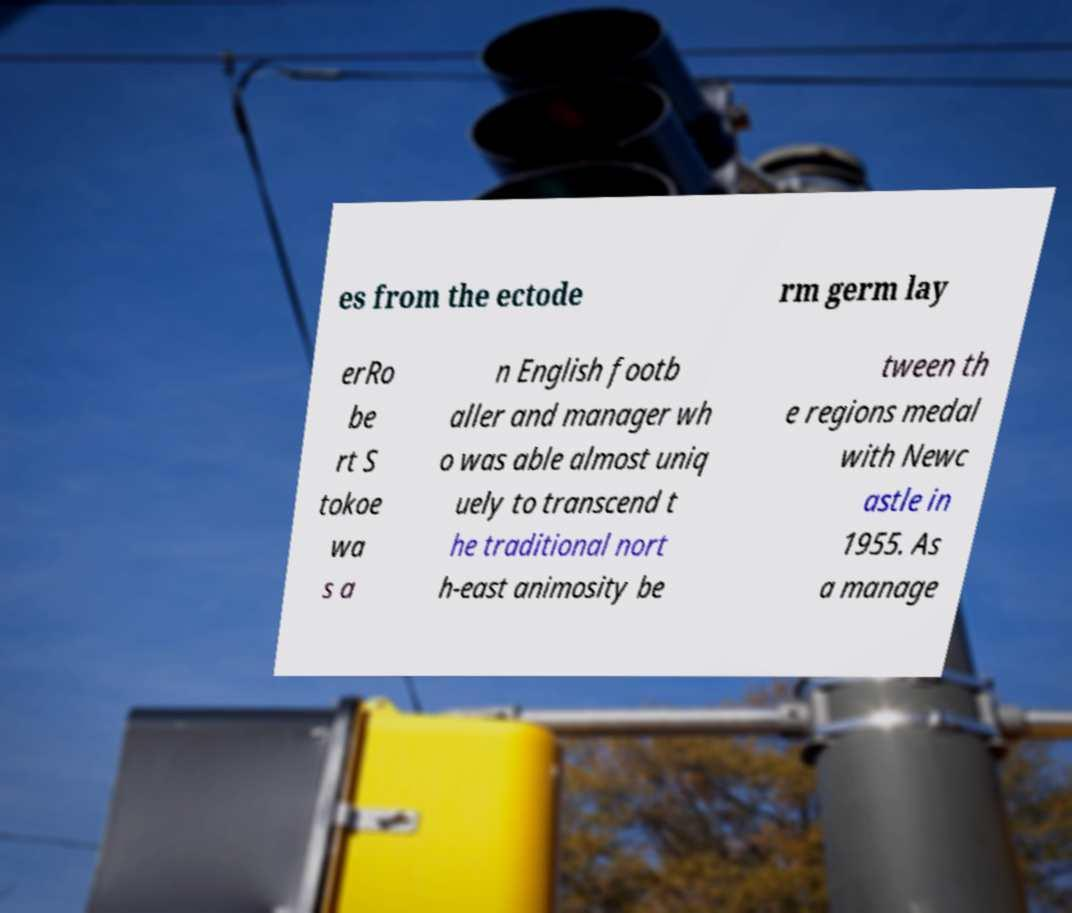I need the written content from this picture converted into text. Can you do that? es from the ectode rm germ lay erRo be rt S tokoe wa s a n English footb aller and manager wh o was able almost uniq uely to transcend t he traditional nort h-east animosity be tween th e regions medal with Newc astle in 1955. As a manage 